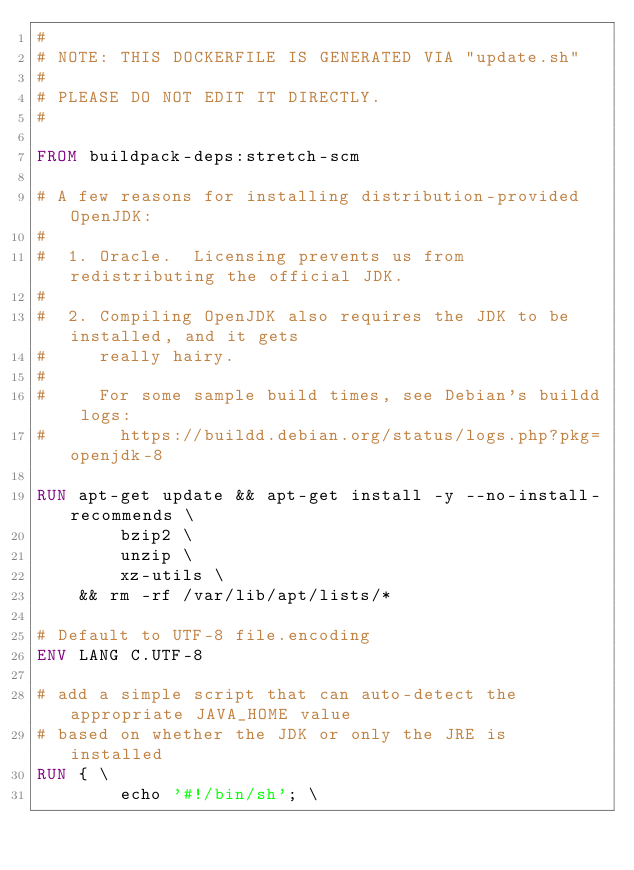<code> <loc_0><loc_0><loc_500><loc_500><_Dockerfile_>#
# NOTE: THIS DOCKERFILE IS GENERATED VIA "update.sh"
#
# PLEASE DO NOT EDIT IT DIRECTLY.
#

FROM buildpack-deps:stretch-scm

# A few reasons for installing distribution-provided OpenJDK:
#
#  1. Oracle.  Licensing prevents us from redistributing the official JDK.
#
#  2. Compiling OpenJDK also requires the JDK to be installed, and it gets
#     really hairy.
#
#     For some sample build times, see Debian's buildd logs:
#       https://buildd.debian.org/status/logs.php?pkg=openjdk-8

RUN apt-get update && apt-get install -y --no-install-recommends \
		bzip2 \
		unzip \
		xz-utils \
	&& rm -rf /var/lib/apt/lists/*

# Default to UTF-8 file.encoding
ENV LANG C.UTF-8

# add a simple script that can auto-detect the appropriate JAVA_HOME value
# based on whether the JDK or only the JRE is installed
RUN { \
		echo '#!/bin/sh'; \</code> 